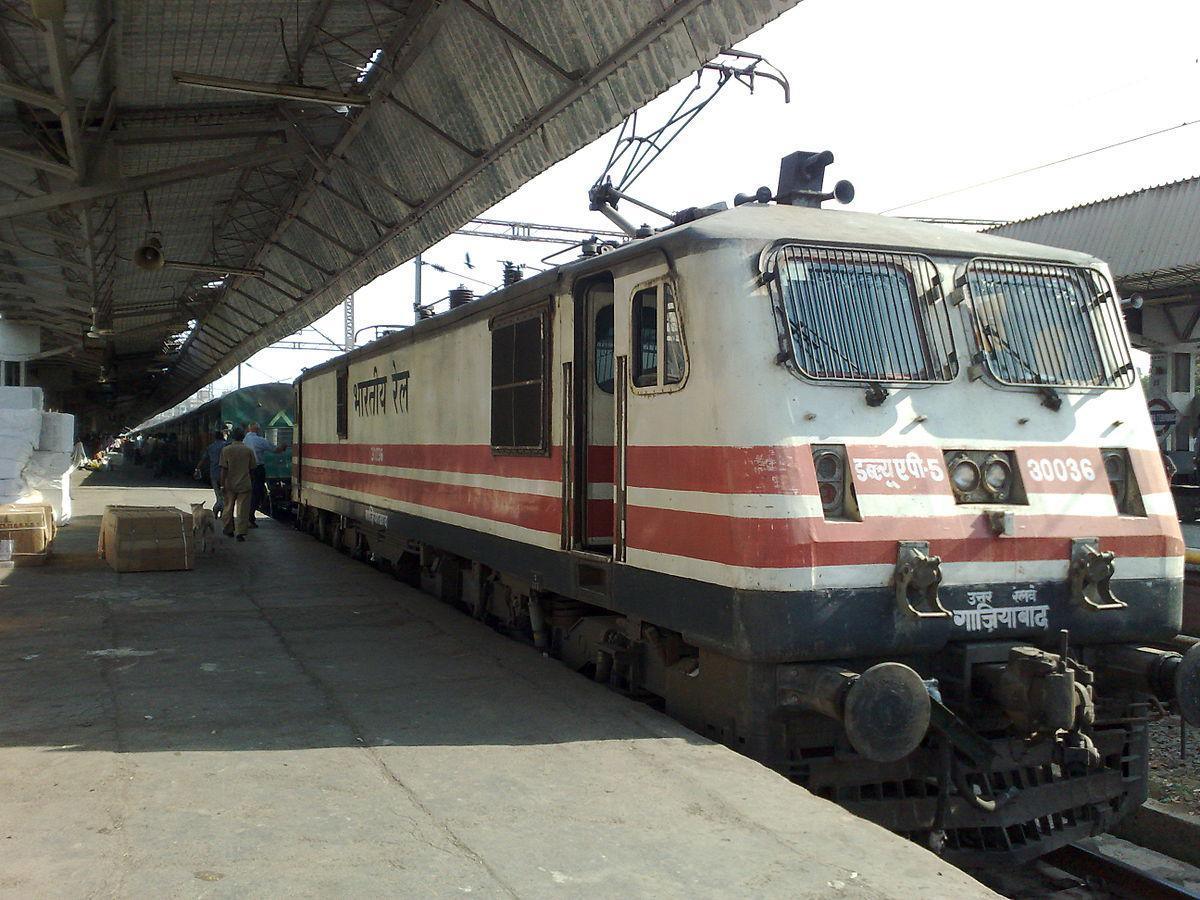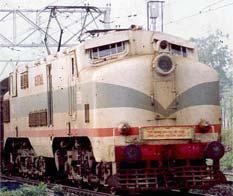The first image is the image on the left, the second image is the image on the right. Given the left and right images, does the statement "One train has a blue body and a white top that extends in an upside-down V-shape on the front of the train." hold true? Answer yes or no. No. 